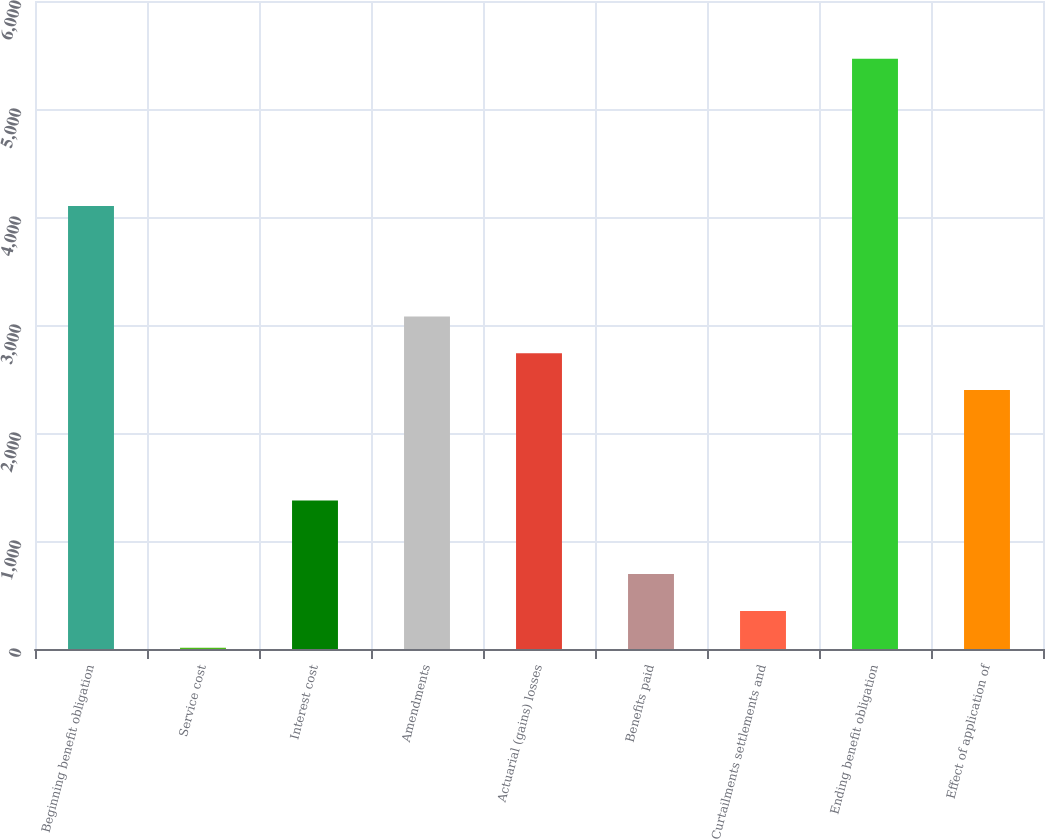Convert chart. <chart><loc_0><loc_0><loc_500><loc_500><bar_chart><fcel>Beginning benefit obligation<fcel>Service cost<fcel>Interest cost<fcel>Amendments<fcel>Actuarial (gains) losses<fcel>Benefits paid<fcel>Curtailments settlements and<fcel>Ending benefit obligation<fcel>Effect of application of<nl><fcel>4101.6<fcel>12<fcel>1375.2<fcel>3079.2<fcel>2738.4<fcel>693.6<fcel>352.8<fcel>5464.8<fcel>2397.6<nl></chart> 